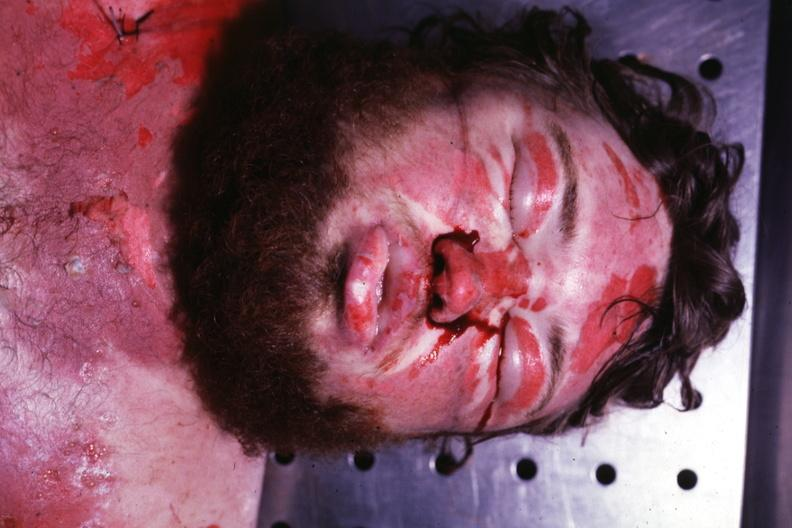s face present?
Answer the question using a single word or phrase. Yes 